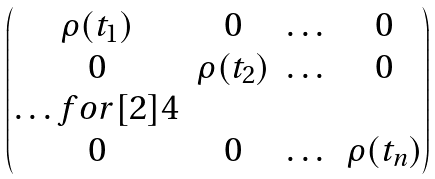Convert formula to latex. <formula><loc_0><loc_0><loc_500><loc_500>\begin{pmatrix} \rho ( t _ { 1 } ) & 0 & \dots & 0 \\ 0 & \rho ( t _ { 2 } ) & \dots & 0 \\ \hdots f o r [ 2 ] { 4 } \\ 0 & 0 & \dots & \rho ( t _ { n } ) \end{pmatrix}</formula> 